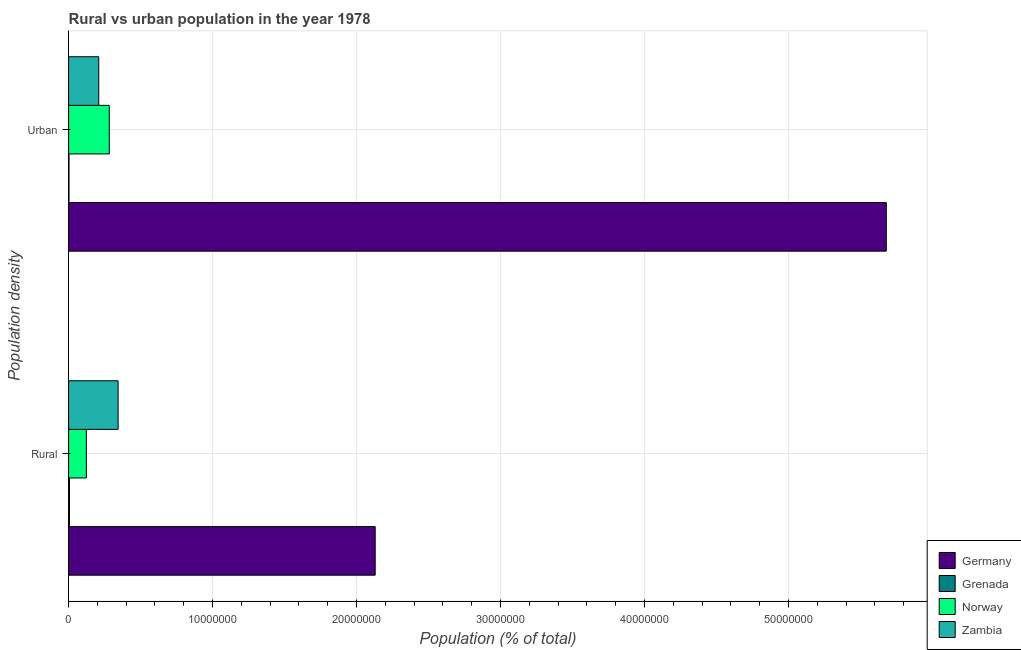How many different coloured bars are there?
Provide a short and direct response. 4. How many groups of bars are there?
Your answer should be very brief. 2. Are the number of bars per tick equal to the number of legend labels?
Offer a terse response. Yes. How many bars are there on the 1st tick from the bottom?
Offer a very short reply. 4. What is the label of the 2nd group of bars from the top?
Keep it short and to the point. Rural. What is the urban population density in Grenada?
Your response must be concise. 2.92e+04. Across all countries, what is the maximum rural population density?
Your response must be concise. 2.13e+07. Across all countries, what is the minimum rural population density?
Offer a very short reply. 5.99e+04. In which country was the rural population density minimum?
Ensure brevity in your answer.  Grenada. What is the total urban population density in the graph?
Offer a very short reply. 6.17e+07. What is the difference between the rural population density in Norway and that in Germany?
Provide a short and direct response. -2.01e+07. What is the difference between the rural population density in Germany and the urban population density in Norway?
Offer a very short reply. 1.85e+07. What is the average rural population density per country?
Your answer should be compact. 6.51e+06. What is the difference between the rural population density and urban population density in Grenada?
Provide a short and direct response. 3.07e+04. What is the ratio of the rural population density in Norway to that in Germany?
Provide a succinct answer. 0.06. Is the rural population density in Norway less than that in Zambia?
Keep it short and to the point. Yes. In how many countries, is the urban population density greater than the average urban population density taken over all countries?
Your response must be concise. 1. What does the 1st bar from the top in Rural represents?
Provide a succinct answer. Zambia. What does the 4th bar from the bottom in Rural represents?
Give a very brief answer. Zambia. How many countries are there in the graph?
Offer a terse response. 4. How many legend labels are there?
Ensure brevity in your answer.  4. How are the legend labels stacked?
Make the answer very short. Vertical. What is the title of the graph?
Provide a succinct answer. Rural vs urban population in the year 1978. What is the label or title of the X-axis?
Ensure brevity in your answer.  Population (% of total). What is the label or title of the Y-axis?
Offer a very short reply. Population density. What is the Population (% of total) in Germany in Rural?
Offer a terse response. 2.13e+07. What is the Population (% of total) of Grenada in Rural?
Ensure brevity in your answer.  5.99e+04. What is the Population (% of total) in Norway in Rural?
Your answer should be compact. 1.23e+06. What is the Population (% of total) of Zambia in Rural?
Provide a short and direct response. 3.44e+06. What is the Population (% of total) of Germany in Urban?
Your answer should be very brief. 5.68e+07. What is the Population (% of total) in Grenada in Urban?
Ensure brevity in your answer.  2.92e+04. What is the Population (% of total) of Norway in Urban?
Offer a very short reply. 2.83e+06. What is the Population (% of total) in Zambia in Urban?
Keep it short and to the point. 2.09e+06. Across all Population density, what is the maximum Population (% of total) of Germany?
Provide a succinct answer. 5.68e+07. Across all Population density, what is the maximum Population (% of total) of Grenada?
Provide a short and direct response. 5.99e+04. Across all Population density, what is the maximum Population (% of total) of Norway?
Provide a succinct answer. 2.83e+06. Across all Population density, what is the maximum Population (% of total) of Zambia?
Provide a short and direct response. 3.44e+06. Across all Population density, what is the minimum Population (% of total) in Germany?
Offer a terse response. 2.13e+07. Across all Population density, what is the minimum Population (% of total) of Grenada?
Your answer should be very brief. 2.92e+04. Across all Population density, what is the minimum Population (% of total) in Norway?
Your answer should be very brief. 1.23e+06. Across all Population density, what is the minimum Population (% of total) of Zambia?
Offer a terse response. 2.09e+06. What is the total Population (% of total) of Germany in the graph?
Give a very brief answer. 7.81e+07. What is the total Population (% of total) in Grenada in the graph?
Give a very brief answer. 8.91e+04. What is the total Population (% of total) of Norway in the graph?
Your answer should be compact. 4.06e+06. What is the total Population (% of total) of Zambia in the graph?
Your answer should be compact. 5.53e+06. What is the difference between the Population (% of total) of Germany in Rural and that in Urban?
Make the answer very short. -3.55e+07. What is the difference between the Population (% of total) in Grenada in Rural and that in Urban?
Give a very brief answer. 3.07e+04. What is the difference between the Population (% of total) in Norway in Rural and that in Urban?
Your answer should be very brief. -1.59e+06. What is the difference between the Population (% of total) of Zambia in Rural and that in Urban?
Offer a terse response. 1.35e+06. What is the difference between the Population (% of total) in Germany in Rural and the Population (% of total) in Grenada in Urban?
Offer a very short reply. 2.13e+07. What is the difference between the Population (% of total) in Germany in Rural and the Population (% of total) in Norway in Urban?
Keep it short and to the point. 1.85e+07. What is the difference between the Population (% of total) in Germany in Rural and the Population (% of total) in Zambia in Urban?
Provide a short and direct response. 1.92e+07. What is the difference between the Population (% of total) in Grenada in Rural and the Population (% of total) in Norway in Urban?
Provide a short and direct response. -2.77e+06. What is the difference between the Population (% of total) of Grenada in Rural and the Population (% of total) of Zambia in Urban?
Offer a terse response. -2.03e+06. What is the difference between the Population (% of total) in Norway in Rural and the Population (% of total) in Zambia in Urban?
Make the answer very short. -8.60e+05. What is the average Population (% of total) in Germany per Population density?
Ensure brevity in your answer.  3.90e+07. What is the average Population (% of total) in Grenada per Population density?
Your response must be concise. 4.45e+04. What is the average Population (% of total) in Norway per Population density?
Provide a succinct answer. 2.03e+06. What is the average Population (% of total) in Zambia per Population density?
Provide a short and direct response. 2.77e+06. What is the difference between the Population (% of total) of Germany and Population (% of total) of Grenada in Rural?
Give a very brief answer. 2.12e+07. What is the difference between the Population (% of total) of Germany and Population (% of total) of Norway in Rural?
Your answer should be compact. 2.01e+07. What is the difference between the Population (% of total) of Germany and Population (% of total) of Zambia in Rural?
Your answer should be very brief. 1.79e+07. What is the difference between the Population (% of total) of Grenada and Population (% of total) of Norway in Rural?
Provide a short and direct response. -1.17e+06. What is the difference between the Population (% of total) in Grenada and Population (% of total) in Zambia in Rural?
Your response must be concise. -3.38e+06. What is the difference between the Population (% of total) of Norway and Population (% of total) of Zambia in Rural?
Keep it short and to the point. -2.21e+06. What is the difference between the Population (% of total) in Germany and Population (% of total) in Grenada in Urban?
Keep it short and to the point. 5.68e+07. What is the difference between the Population (% of total) in Germany and Population (% of total) in Norway in Urban?
Offer a very short reply. 5.40e+07. What is the difference between the Population (% of total) in Germany and Population (% of total) in Zambia in Urban?
Make the answer very short. 5.47e+07. What is the difference between the Population (% of total) of Grenada and Population (% of total) of Norway in Urban?
Provide a succinct answer. -2.80e+06. What is the difference between the Population (% of total) of Grenada and Population (% of total) of Zambia in Urban?
Give a very brief answer. -2.06e+06. What is the difference between the Population (% of total) of Norway and Population (% of total) of Zambia in Urban?
Ensure brevity in your answer.  7.32e+05. What is the ratio of the Population (% of total) of Germany in Rural to that in Urban?
Your answer should be very brief. 0.37. What is the ratio of the Population (% of total) in Grenada in Rural to that in Urban?
Your answer should be very brief. 2.05. What is the ratio of the Population (% of total) in Norway in Rural to that in Urban?
Provide a short and direct response. 0.44. What is the ratio of the Population (% of total) in Zambia in Rural to that in Urban?
Your answer should be compact. 1.64. What is the difference between the highest and the second highest Population (% of total) of Germany?
Keep it short and to the point. 3.55e+07. What is the difference between the highest and the second highest Population (% of total) of Grenada?
Offer a terse response. 3.07e+04. What is the difference between the highest and the second highest Population (% of total) in Norway?
Your answer should be very brief. 1.59e+06. What is the difference between the highest and the second highest Population (% of total) in Zambia?
Ensure brevity in your answer.  1.35e+06. What is the difference between the highest and the lowest Population (% of total) of Germany?
Make the answer very short. 3.55e+07. What is the difference between the highest and the lowest Population (% of total) of Grenada?
Provide a short and direct response. 3.07e+04. What is the difference between the highest and the lowest Population (% of total) in Norway?
Make the answer very short. 1.59e+06. What is the difference between the highest and the lowest Population (% of total) in Zambia?
Your response must be concise. 1.35e+06. 